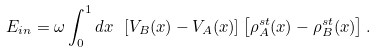<formula> <loc_0><loc_0><loc_500><loc_500>E _ { i n } = \omega \int _ { 0 } ^ { 1 } d x \ \left [ V _ { B } ( x ) - V _ { A } ( x ) \right ] \left [ \rho ^ { s t } _ { A } ( x ) - \rho ^ { s t } _ { B } ( x ) \right ] .</formula> 